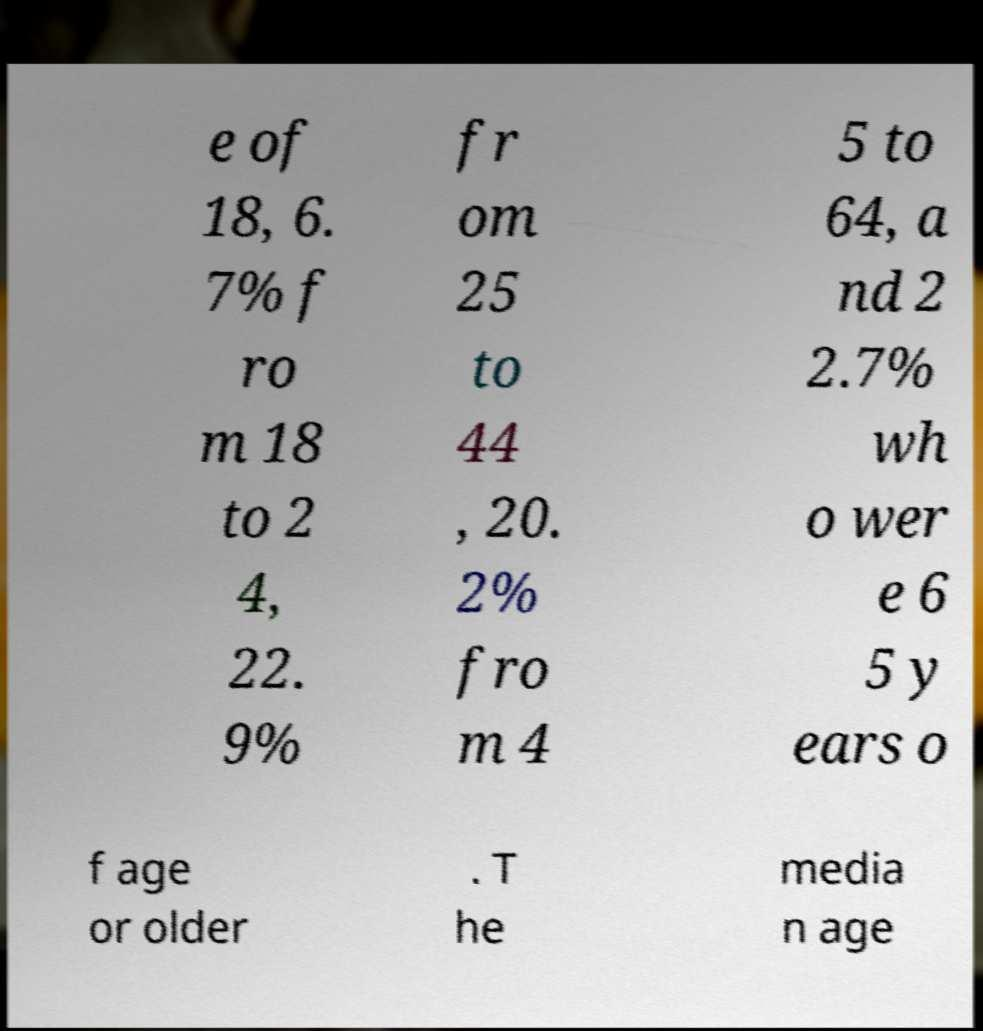Can you read and provide the text displayed in the image?This photo seems to have some interesting text. Can you extract and type it out for me? e of 18, 6. 7% f ro m 18 to 2 4, 22. 9% fr om 25 to 44 , 20. 2% fro m 4 5 to 64, a nd 2 2.7% wh o wer e 6 5 y ears o f age or older . T he media n age 